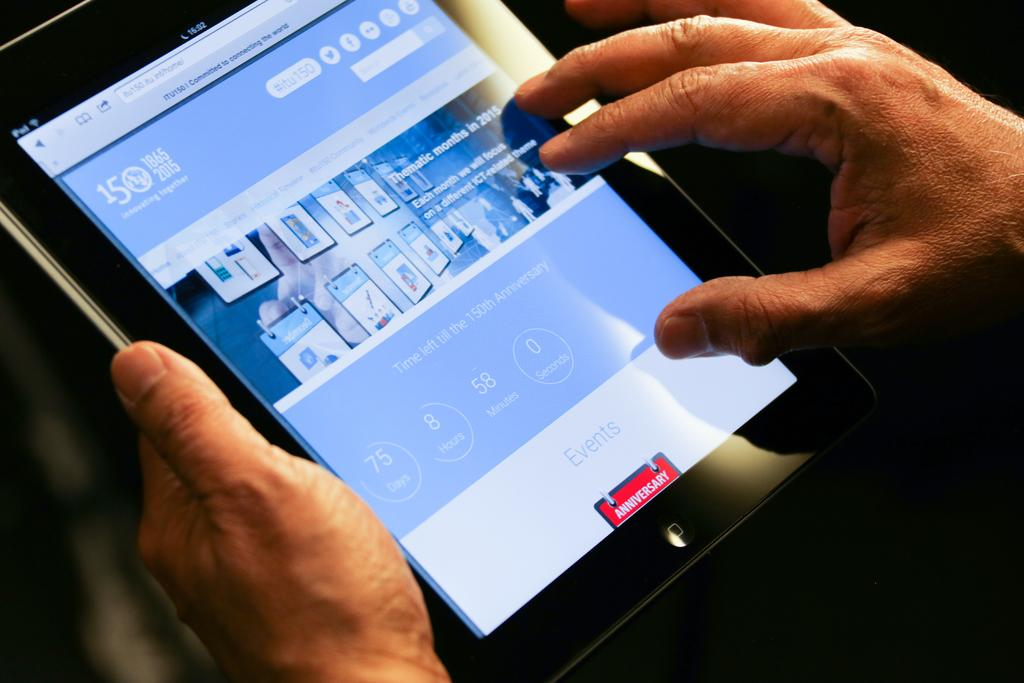What electronic device is visible in the image? There is an iPad in the image. Who is interacting with the iPad? A person is holding the iPad. How many dogs are present in the image? There are no dogs present in the image; it only features a person holding an iPad. What territory is being claimed by the horse in the image? There is no horse present in the image, so no territory is being claimed. 